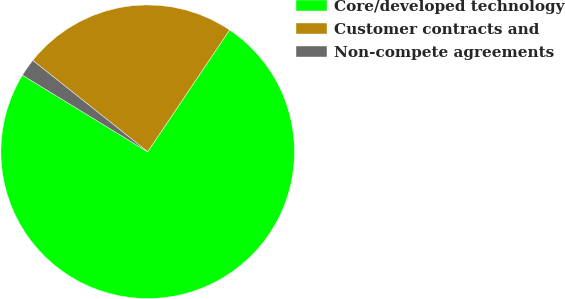Convert chart to OTSL. <chart><loc_0><loc_0><loc_500><loc_500><pie_chart><fcel>Core/developed technology<fcel>Customer contracts and<fcel>Non-compete agreements<nl><fcel>74.32%<fcel>23.74%<fcel>1.95%<nl></chart> 